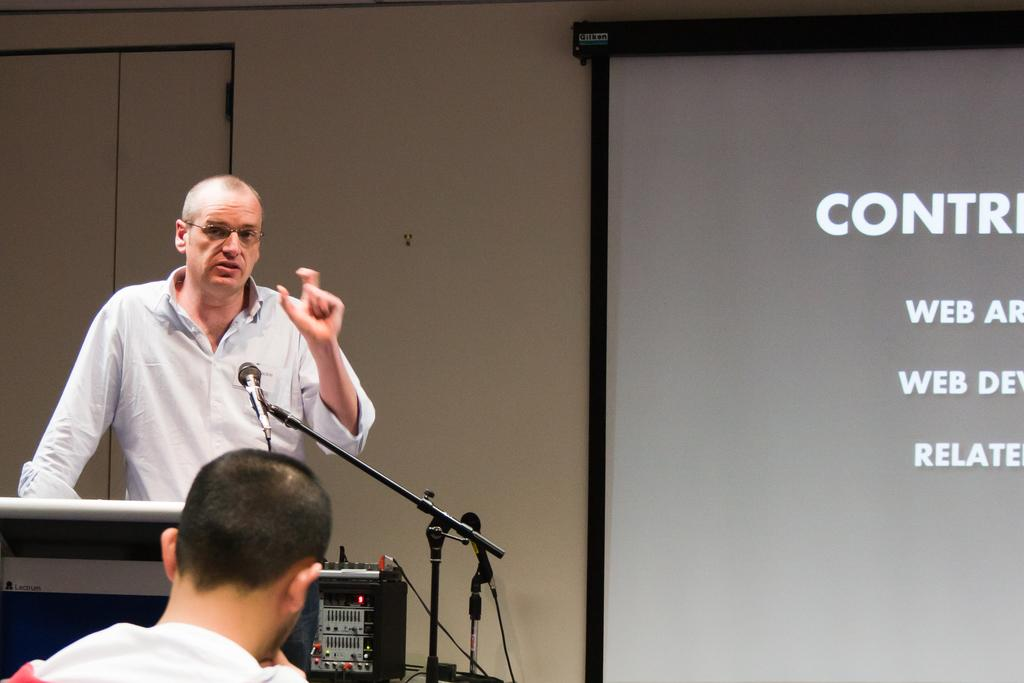What is the person in the image doing? The person is standing on a dais and speaking in front of a microphone. What might be used to amplify the person's voice in the image? The person is speaking in front of a microphone, which is used to amplify their voice. What is located behind the person in the image? There is a screen behind the person. What type of drink is the person holding while speaking in the image? There is no drink visible in the image; the person is holding a microphone. 